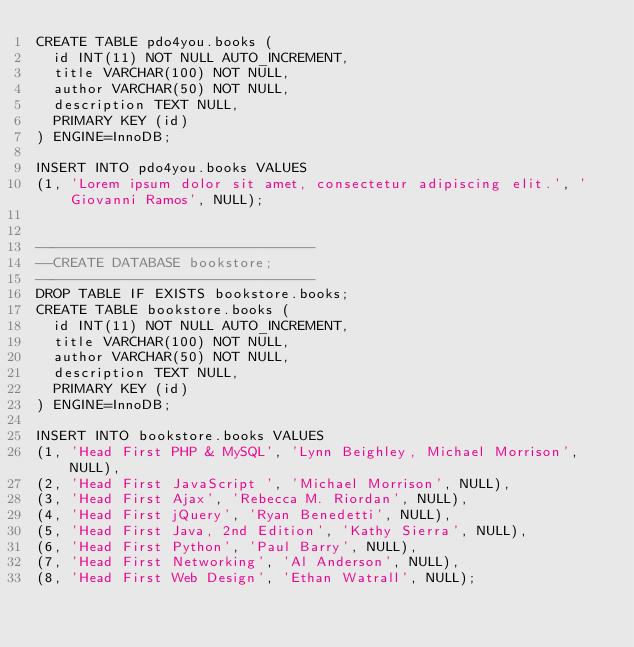Convert code to text. <code><loc_0><loc_0><loc_500><loc_500><_SQL_>CREATE TABLE pdo4you.books (
	id INT(11) NOT NULL AUTO_INCREMENT,
	title VARCHAR(100) NOT NULL,
	author VARCHAR(50) NOT NULL,
	description TEXT NULL,
	PRIMARY KEY (id)
) ENGINE=InnoDB;

INSERT INTO pdo4you.books VALUES 
(1, 'Lorem ipsum dolor sit amet, consectetur adipiscing elit.', 'Giovanni Ramos', NULL);


---------------------------------
--CREATE DATABASE bookstore;
---------------------------------
DROP TABLE IF EXISTS bookstore.books;
CREATE TABLE bookstore.books (
	id INT(11) NOT NULL AUTO_INCREMENT,
	title VARCHAR(100) NOT NULL,
	author VARCHAR(50) NOT NULL,
	description TEXT NULL,
	PRIMARY KEY (id)
) ENGINE=InnoDB;

INSERT INTO bookstore.books VALUES 
(1, 'Head First PHP & MySQL', 'Lynn Beighley, Michael Morrison', NULL),
(2, 'Head First JavaScript ', 'Michael Morrison', NULL),
(3, 'Head First Ajax', 'Rebecca M. Riordan', NULL),
(4, 'Head First jQuery', 'Ryan Benedetti', NULL),
(5, 'Head First Java, 2nd Edition', 'Kathy Sierra', NULL),
(6, 'Head First Python', 'Paul Barry', NULL),
(7, 'Head First Networking', 'Al Anderson', NULL),
(8, 'Head First Web Design', 'Ethan Watrall', NULL);
</code> 